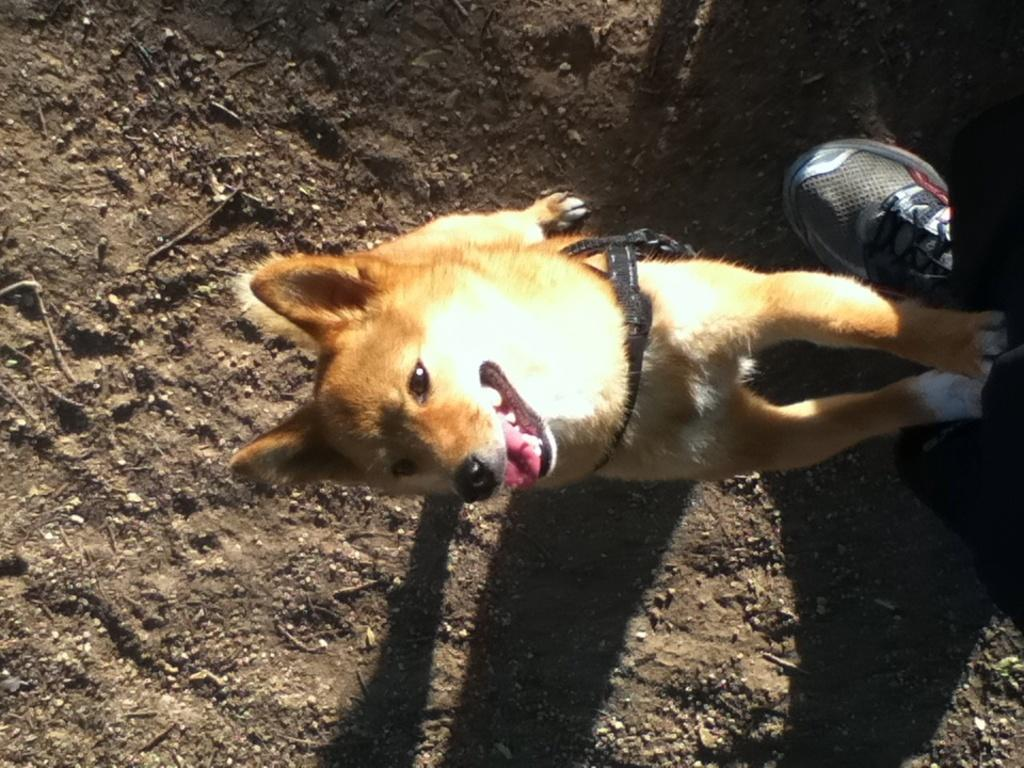What type of animal is in the picture? There is a dog in the picture. What is the dog wearing? The dog is wearing a neck belt. What else can be seen in the image? There is a shoe on the right side of the image. How many divisions are visible in the dog's wound in the image? There is no wound present on the dog in the image, and therefore no divisions can be observed. 